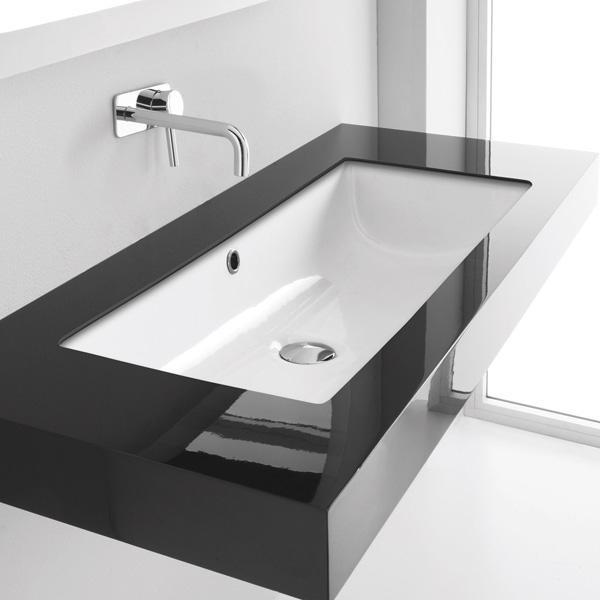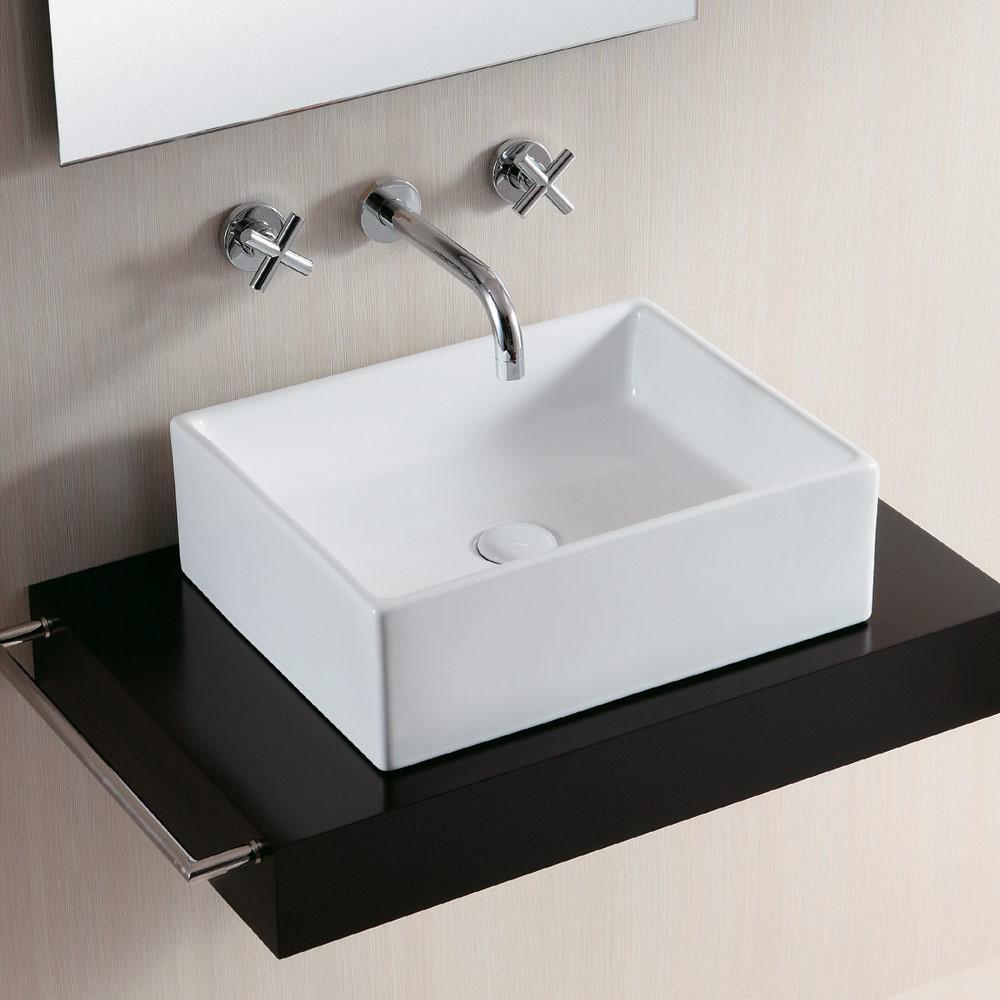The first image is the image on the left, the second image is the image on the right. Assess this claim about the two images: "Each sink is rectangular". Correct or not? Answer yes or no. Yes. The first image is the image on the left, the second image is the image on the right. Assess this claim about the two images: "The left image shows one rectangular sink which is inset and has a wide counter, and the right image shows a sink that is more square and does not have a wide counter.". Correct or not? Answer yes or no. Yes. 